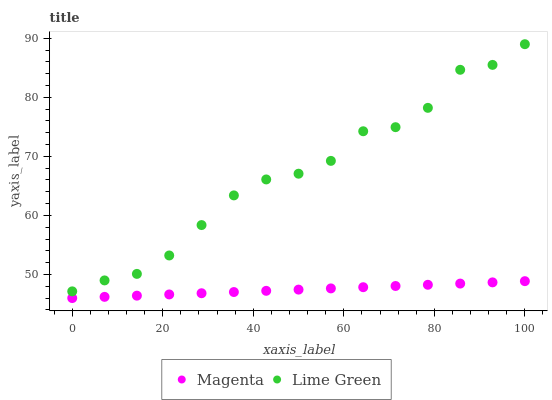Does Magenta have the minimum area under the curve?
Answer yes or no. Yes. Does Lime Green have the maximum area under the curve?
Answer yes or no. Yes. Does Lime Green have the minimum area under the curve?
Answer yes or no. No. Is Magenta the smoothest?
Answer yes or no. Yes. Is Lime Green the roughest?
Answer yes or no. Yes. Is Lime Green the smoothest?
Answer yes or no. No. Does Magenta have the lowest value?
Answer yes or no. Yes. Does Lime Green have the lowest value?
Answer yes or no. No. Does Lime Green have the highest value?
Answer yes or no. Yes. Is Magenta less than Lime Green?
Answer yes or no. Yes. Is Lime Green greater than Magenta?
Answer yes or no. Yes. Does Magenta intersect Lime Green?
Answer yes or no. No. 